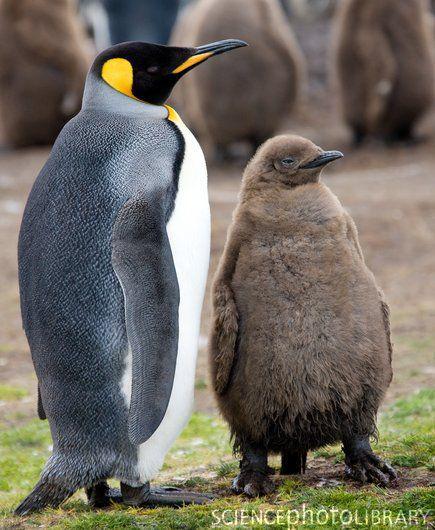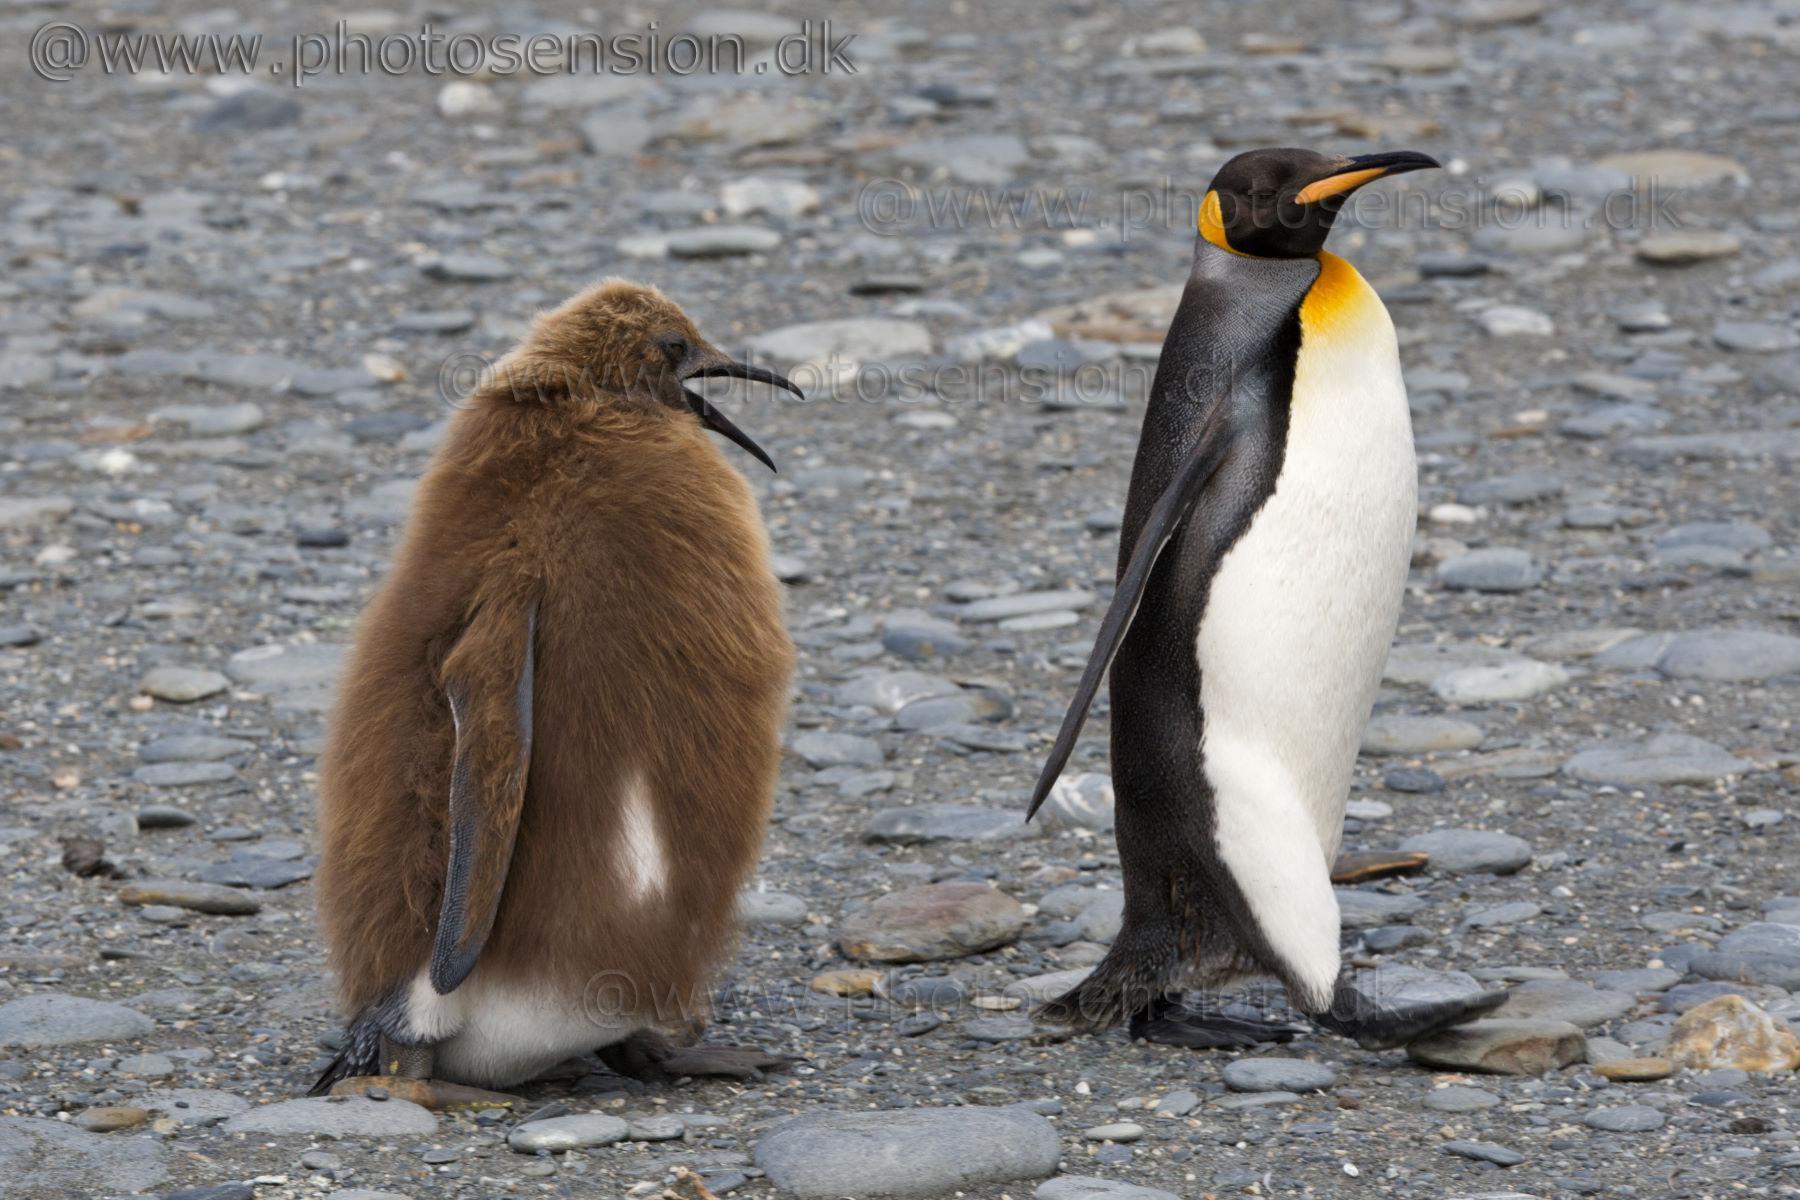The first image is the image on the left, the second image is the image on the right. Analyze the images presented: Is the assertion "There is one king penguin and one brown furry penguin in the right image." valid? Answer yes or no. Yes. The first image is the image on the left, the second image is the image on the right. Evaluate the accuracy of this statement regarding the images: "There is exactly two penguins in the right image.". Is it true? Answer yes or no. Yes. 